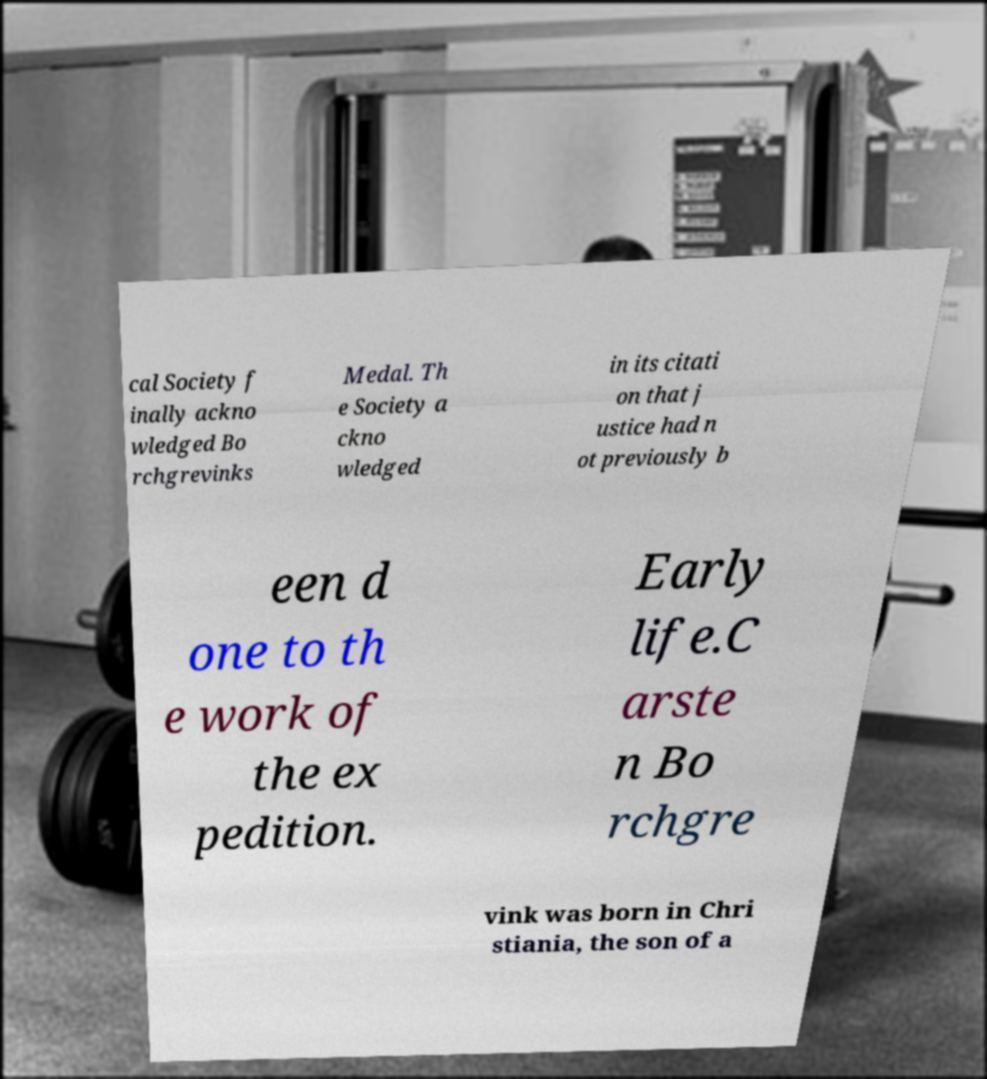Can you read and provide the text displayed in the image?This photo seems to have some interesting text. Can you extract and type it out for me? cal Society f inally ackno wledged Bo rchgrevinks Medal. Th e Society a ckno wledged in its citati on that j ustice had n ot previously b een d one to th e work of the ex pedition. Early life.C arste n Bo rchgre vink was born in Chri stiania, the son of a 